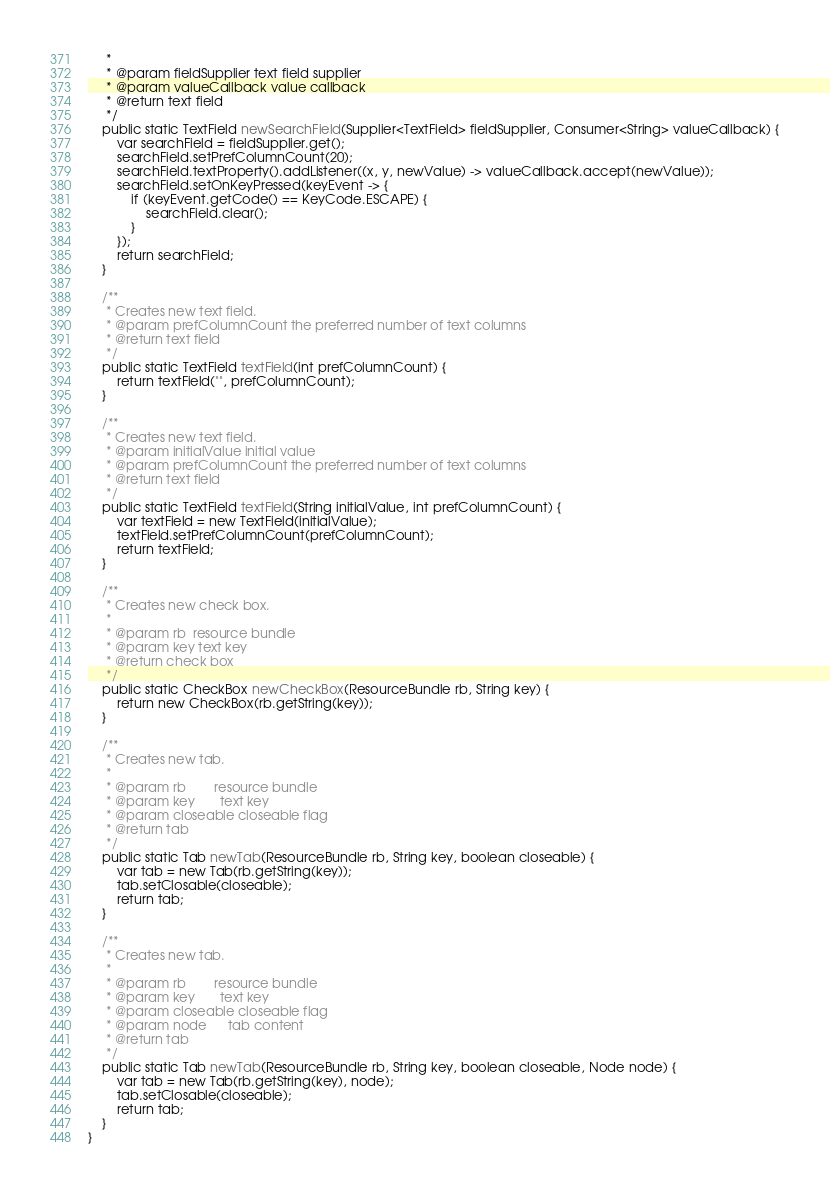<code> <loc_0><loc_0><loc_500><loc_500><_Java_>     *
     * @param fieldSupplier text field supplier
     * @param valueCallback value callback
     * @return text field
     */
    public static TextField newSearchField(Supplier<TextField> fieldSupplier, Consumer<String> valueCallback) {
        var searchField = fieldSupplier.get();
        searchField.setPrefColumnCount(20);
        searchField.textProperty().addListener((x, y, newValue) -> valueCallback.accept(newValue));
        searchField.setOnKeyPressed(keyEvent -> {
            if (keyEvent.getCode() == KeyCode.ESCAPE) {
                searchField.clear();
            }
        });
        return searchField;
    }

    /**
     * Creates new text field.
     * @param prefColumnCount the preferred number of text columns
     * @return text field
     */
    public static TextField textField(int prefColumnCount) {
        return textField("", prefColumnCount);
    }

    /**
     * Creates new text field.
     * @param initialValue initial value
     * @param prefColumnCount the preferred number of text columns
     * @return text field
     */
    public static TextField textField(String initialValue, int prefColumnCount) {
        var textField = new TextField(initialValue);
        textField.setPrefColumnCount(prefColumnCount);
        return textField;
    }

    /**
     * Creates new check box.
     *
     * @param rb  resource bundle
     * @param key text key
     * @return check box
     */
    public static CheckBox newCheckBox(ResourceBundle rb, String key) {
        return new CheckBox(rb.getString(key));
    }

    /**
     * Creates new tab.
     *
     * @param rb        resource bundle
     * @param key       text key
     * @param closeable closeable flag
     * @return tab
     */
    public static Tab newTab(ResourceBundle rb, String key, boolean closeable) {
        var tab = new Tab(rb.getString(key));
        tab.setClosable(closeable);
        return tab;
    }

    /**
     * Creates new tab.
     *
     * @param rb        resource bundle
     * @param key       text key
     * @param closeable closeable flag
     * @param node      tab content
     * @return tab
     */
    public static Tab newTab(ResourceBundle rb, String key, boolean closeable, Node node) {
        var tab = new Tab(rb.getString(key), node);
        tab.setClosable(closeable);
        return tab;
    }
}
</code> 